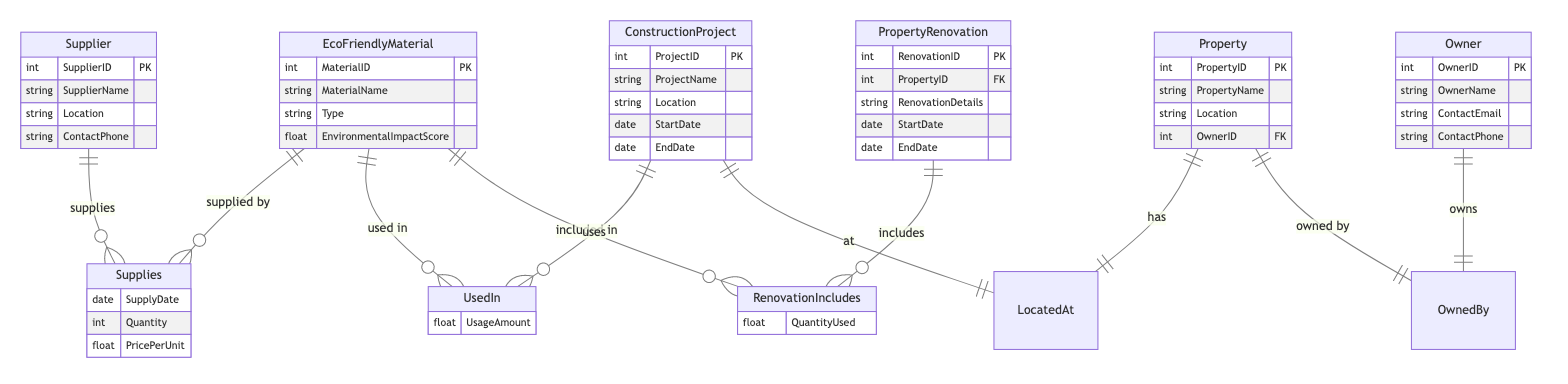What are the keys for the EcoFriendlyMaterial entity? The EcoFriendlyMaterial entity has one primary key, which is MaterialID. This is indicated by the "PK" notation next to MaterialID in the diagram.
Answer: MaterialID How many attributes does the Supplier entity have? The Supplier entity has four attributes: SupplierID, SupplierName, Location, and ContactPhone.
Answer: Four What relationship connects Supplier and EcoFriendlyMaterial? The relationship that connects Supplier and EcoFriendlyMaterial is "Supplies," as indicated in the diagram.
Answer: Supplies How many entities are there in the diagram? The diagram contains six entities: EcoFriendlyMaterial, Supplier, ConstructionProject, PropertyRenovation, Property, and Owner.
Answer: Six What type of material is specifically listed in the EcoFriendlyMaterial entity? The types of materials could vary based on the instances of EcoFriendlyMaterials but example types can include recycled steel and bamboo flooring, as they are common eco-friendly materials.
Answer: Recycled steel, bamboo flooring What is the purpose of the UsedIn relationship? The UsedIn relationship indicates which EcoFriendlyMaterials are utilized in specific ConstructionProjects. The relationship attributes confirm that it tracks the amount used.
Answer: Tracking material usage Which entity represents the owner of the property? The entity that represents the owner of the property is the Owner entity, which includes attributes that identify the property owner.
Answer: Owner How does Property relate to ConstructionProject? The Property is related to ConstructionProject through the "LocatedAt" relationship, indicating the location connection between the two entities.
Answer: LocatedAt What is the attribute that shows how much material was used in PropertyRenovation? The attribute that indicates how much material was used in PropertyRenovation is QuantityUsed, which is part of the RenovationIncludes relationship with EcoFriendlyMaterial.
Answer: QuantityUsed 